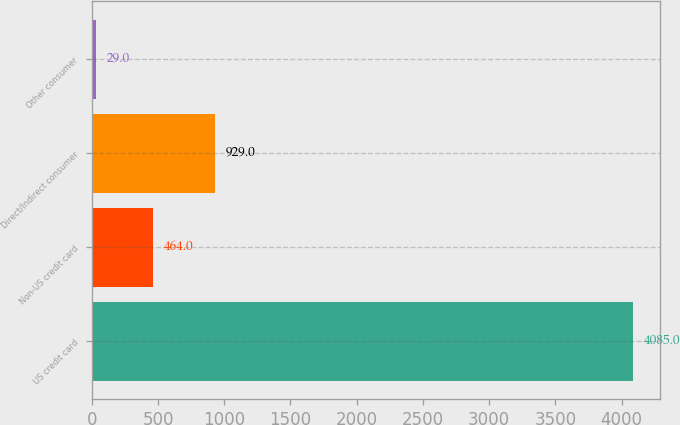Convert chart. <chart><loc_0><loc_0><loc_500><loc_500><bar_chart><fcel>US credit card<fcel>Non-US credit card<fcel>Direct/Indirect consumer<fcel>Other consumer<nl><fcel>4085<fcel>464<fcel>929<fcel>29<nl></chart> 